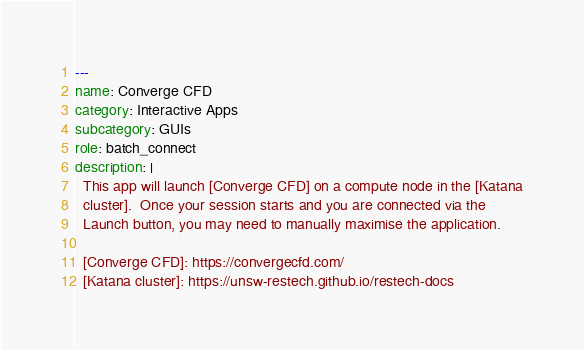<code> <loc_0><loc_0><loc_500><loc_500><_YAML_>---
name: Converge CFD
category: Interactive Apps
subcategory: GUIs
role: batch_connect
description: |
  This app will launch [Converge CFD] on a compute node in the [Katana
  cluster].  Once your session starts and you are connected via the
  Launch button, you may need to manually maximise the application.

  [Converge CFD]: https://convergecfd.com/
  [Katana cluster]: https://unsw-restech.github.io/restech-docs
</code> 